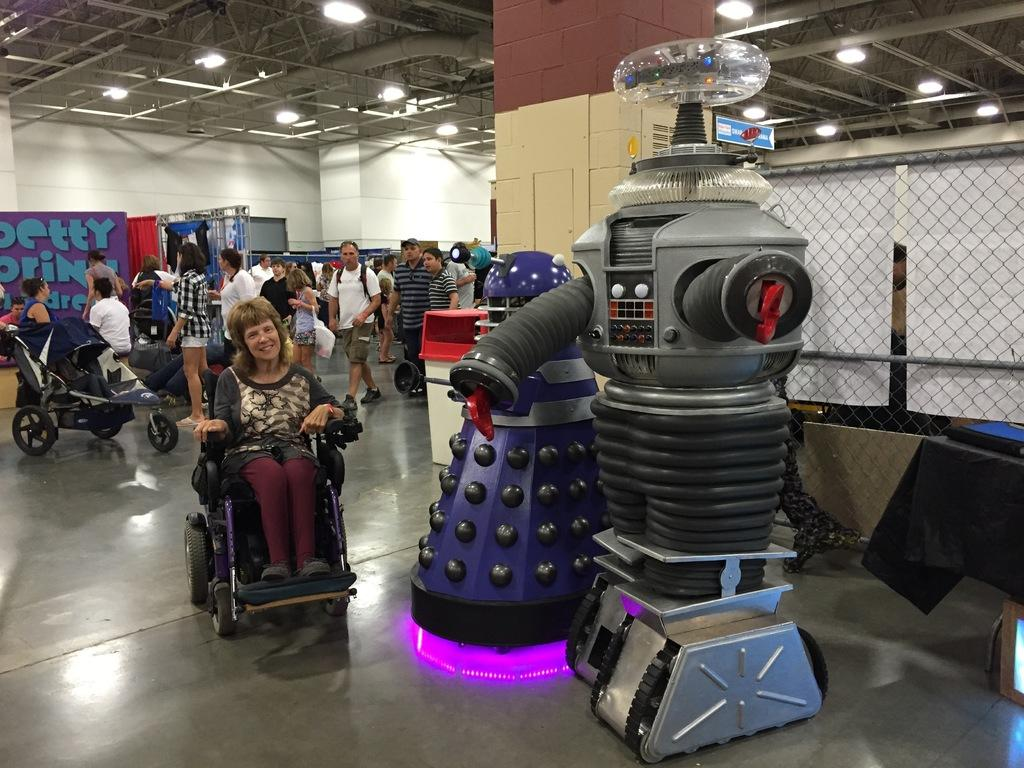What is the main subject of the image? There is a woman in a wheelchair in the image. What can be seen on the right side of the image? There are robots on the right side of the image. What is the position of the people in the image? There are people standing on the floor in the image. What is located on the roof in the image? There are light arrangements on the roof in the image. Is there any grass visible in the image? There is no grass present in the image. Can you describe the slope of the terrain in the image? There is no slope visible in the image; it appears to be a flat surface. 